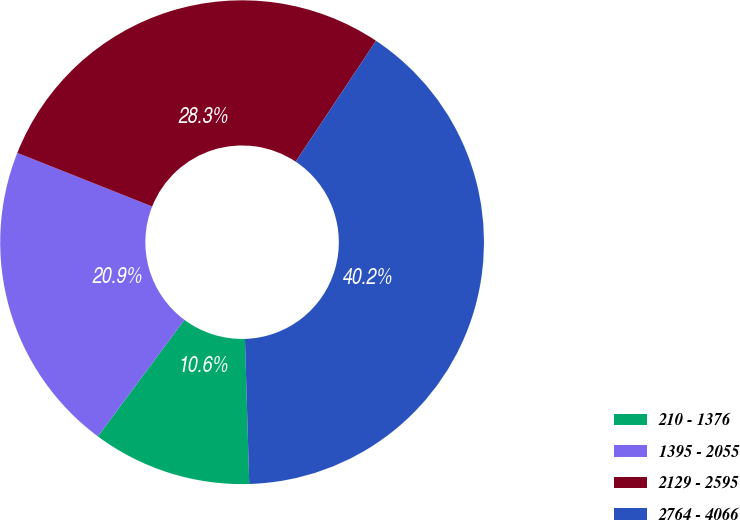Convert chart. <chart><loc_0><loc_0><loc_500><loc_500><pie_chart><fcel>210 - 1376<fcel>1395 - 2055<fcel>2129 - 2595<fcel>2764 - 4066<nl><fcel>10.64%<fcel>20.85%<fcel>28.32%<fcel>40.19%<nl></chart> 